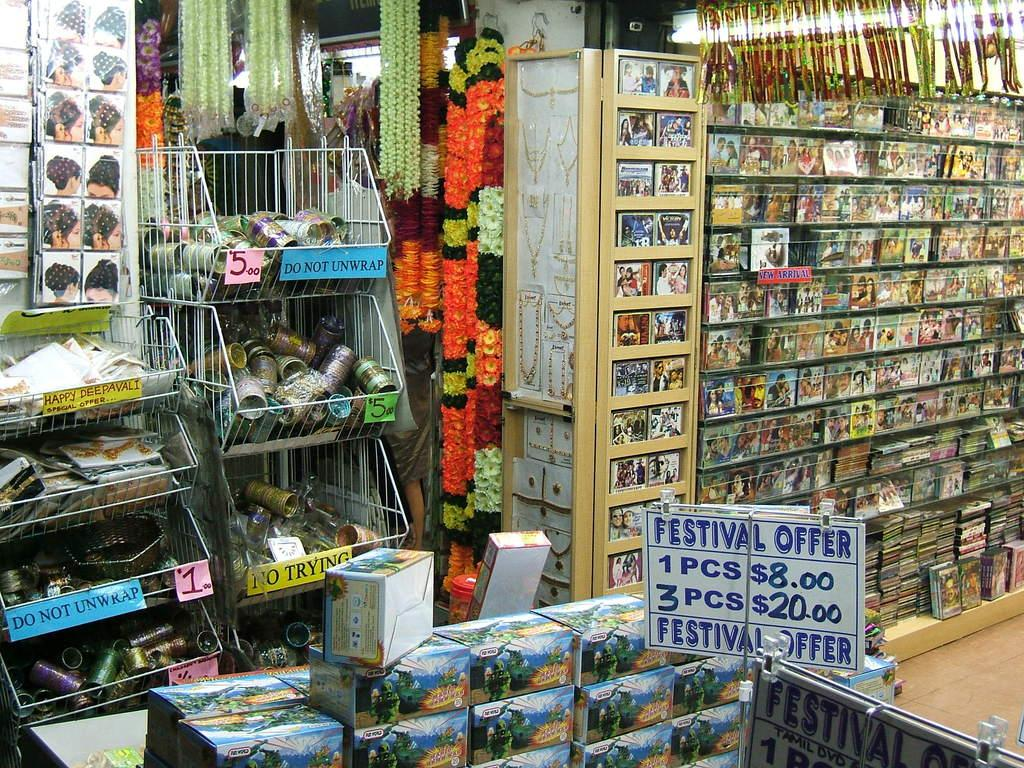<image>
Present a compact description of the photo's key features. One may not try or unwrap any of the items in the bins. 